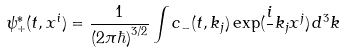Convert formula to latex. <formula><loc_0><loc_0><loc_500><loc_500>\psi _ { + } ^ { * } ( t , x ^ { i } ) = \frac { 1 } { ( 2 \pi \hbar { ) } ^ { 3 / 2 } } \int c _ { - } ( t , k _ { j } ) \exp ( \frac { i } { } k _ { j } x ^ { j } ) \, d ^ { 3 } k</formula> 